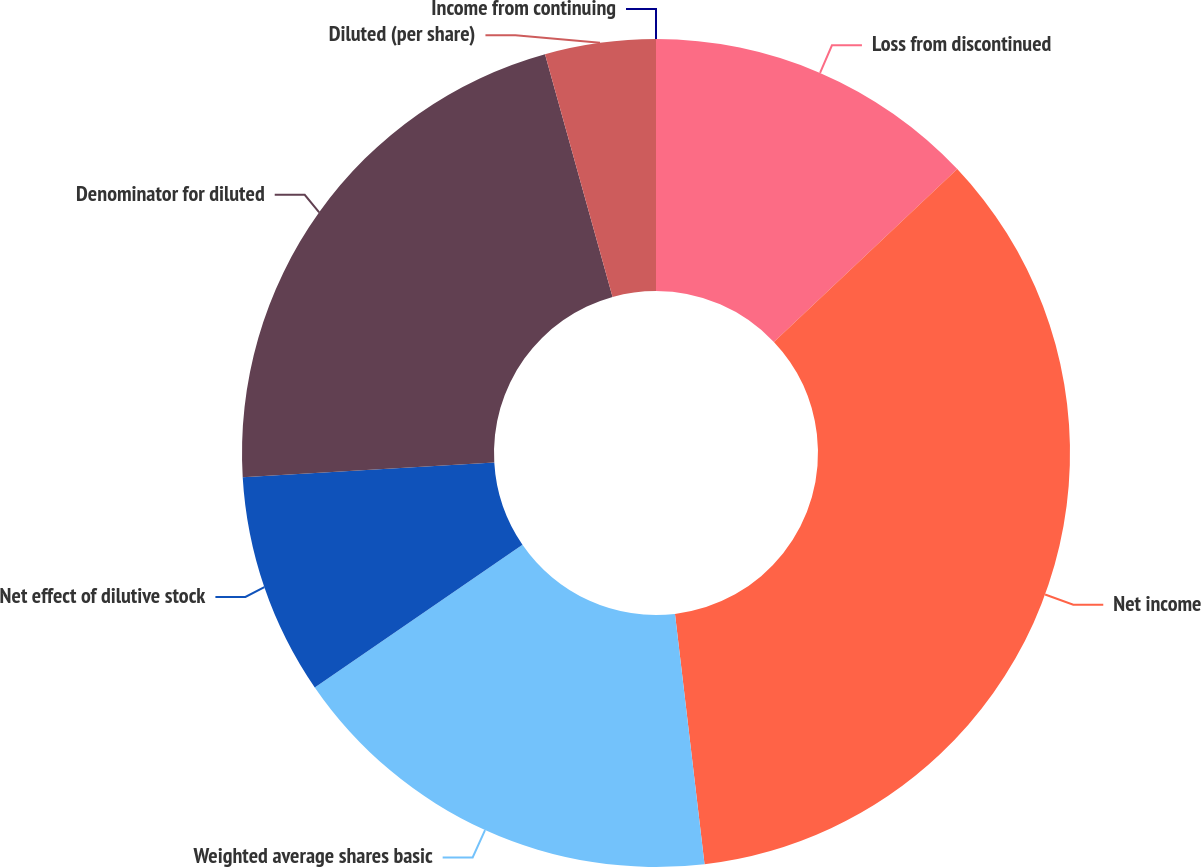Convert chart to OTSL. <chart><loc_0><loc_0><loc_500><loc_500><pie_chart><fcel>Income from continuing<fcel>Loss from discontinued<fcel>Net income<fcel>Weighted average shares basic<fcel>Net effect of dilutive stock<fcel>Denominator for diluted<fcel>Diluted (per share)<nl><fcel>0.0%<fcel>12.97%<fcel>35.16%<fcel>17.29%<fcel>8.65%<fcel>21.61%<fcel>4.32%<nl></chart> 